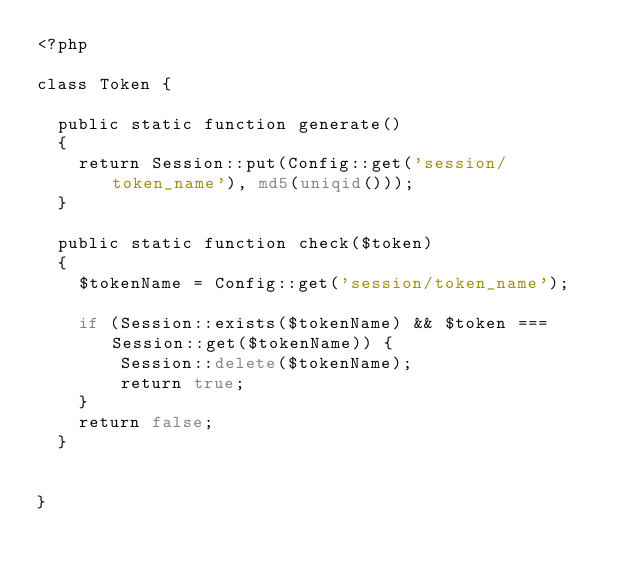<code> <loc_0><loc_0><loc_500><loc_500><_PHP_><?php

class Token {

  public static function generate()
  {
    return Session::put(Config::get('session/token_name'), md5(uniqid()));
  }

  public static function check($token)
  {
    $tokenName = Config::get('session/token_name');

    if (Session::exists($tokenName) && $token === Session::get($tokenName)) {
        Session::delete($tokenName);
        return true;
    }
    return false;
  }


}
</code> 